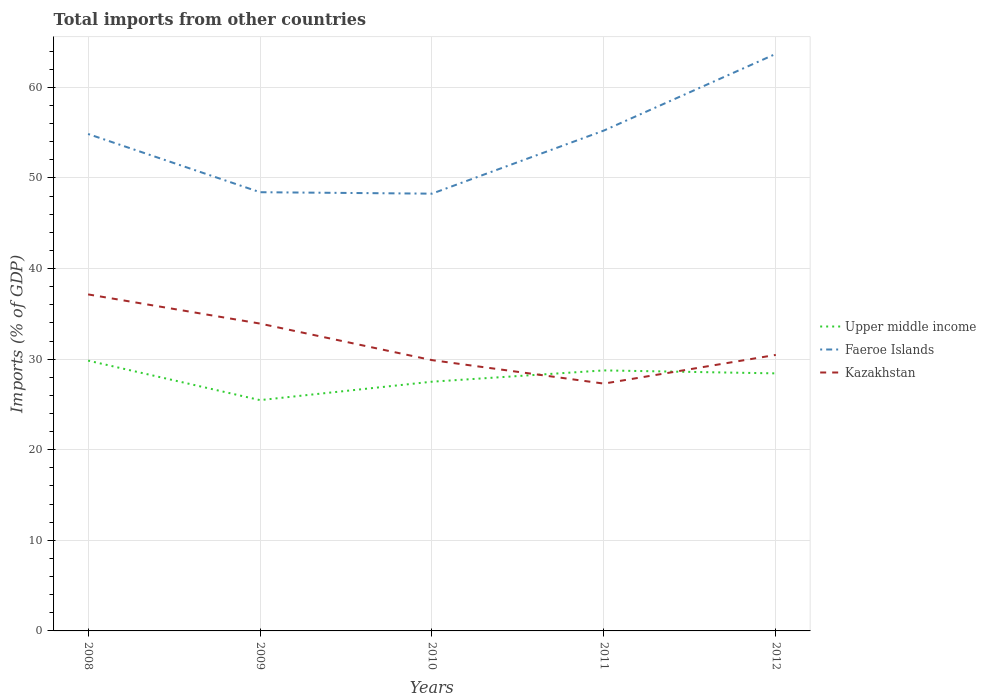How many different coloured lines are there?
Provide a succinct answer. 3. Is the number of lines equal to the number of legend labels?
Offer a terse response. Yes. Across all years, what is the maximum total imports in Faeroe Islands?
Your response must be concise. 48.27. In which year was the total imports in Upper middle income maximum?
Provide a short and direct response. 2009. What is the total total imports in Upper middle income in the graph?
Your answer should be very brief. 4.36. What is the difference between the highest and the second highest total imports in Kazakhstan?
Offer a very short reply. 9.85. What is the difference between the highest and the lowest total imports in Upper middle income?
Your response must be concise. 3. Is the total imports in Faeroe Islands strictly greater than the total imports in Upper middle income over the years?
Your answer should be compact. No. How many years are there in the graph?
Your answer should be compact. 5. What is the difference between two consecutive major ticks on the Y-axis?
Your response must be concise. 10. Where does the legend appear in the graph?
Your answer should be compact. Center right. How are the legend labels stacked?
Your answer should be compact. Vertical. What is the title of the graph?
Your answer should be compact. Total imports from other countries. Does "Iceland" appear as one of the legend labels in the graph?
Your answer should be very brief. No. What is the label or title of the X-axis?
Provide a succinct answer. Years. What is the label or title of the Y-axis?
Keep it short and to the point. Imports (% of GDP). What is the Imports (% of GDP) in Upper middle income in 2008?
Offer a very short reply. 29.84. What is the Imports (% of GDP) of Faeroe Islands in 2008?
Make the answer very short. 54.86. What is the Imports (% of GDP) in Kazakhstan in 2008?
Give a very brief answer. 37.15. What is the Imports (% of GDP) in Upper middle income in 2009?
Provide a short and direct response. 25.48. What is the Imports (% of GDP) of Faeroe Islands in 2009?
Offer a very short reply. 48.43. What is the Imports (% of GDP) in Kazakhstan in 2009?
Give a very brief answer. 33.93. What is the Imports (% of GDP) of Upper middle income in 2010?
Make the answer very short. 27.51. What is the Imports (% of GDP) of Faeroe Islands in 2010?
Your response must be concise. 48.27. What is the Imports (% of GDP) in Kazakhstan in 2010?
Keep it short and to the point. 29.89. What is the Imports (% of GDP) of Upper middle income in 2011?
Ensure brevity in your answer.  28.76. What is the Imports (% of GDP) in Faeroe Islands in 2011?
Your answer should be compact. 55.24. What is the Imports (% of GDP) of Kazakhstan in 2011?
Provide a short and direct response. 27.3. What is the Imports (% of GDP) in Upper middle income in 2012?
Your response must be concise. 28.43. What is the Imports (% of GDP) of Faeroe Islands in 2012?
Give a very brief answer. 63.7. What is the Imports (% of GDP) in Kazakhstan in 2012?
Give a very brief answer. 30.47. Across all years, what is the maximum Imports (% of GDP) of Upper middle income?
Provide a short and direct response. 29.84. Across all years, what is the maximum Imports (% of GDP) in Faeroe Islands?
Your response must be concise. 63.7. Across all years, what is the maximum Imports (% of GDP) of Kazakhstan?
Offer a very short reply. 37.15. Across all years, what is the minimum Imports (% of GDP) in Upper middle income?
Provide a succinct answer. 25.48. Across all years, what is the minimum Imports (% of GDP) in Faeroe Islands?
Give a very brief answer. 48.27. Across all years, what is the minimum Imports (% of GDP) of Kazakhstan?
Give a very brief answer. 27.3. What is the total Imports (% of GDP) in Upper middle income in the graph?
Give a very brief answer. 140.02. What is the total Imports (% of GDP) in Faeroe Islands in the graph?
Provide a short and direct response. 270.49. What is the total Imports (% of GDP) of Kazakhstan in the graph?
Your answer should be very brief. 158.74. What is the difference between the Imports (% of GDP) of Upper middle income in 2008 and that in 2009?
Ensure brevity in your answer.  4.36. What is the difference between the Imports (% of GDP) of Faeroe Islands in 2008 and that in 2009?
Provide a succinct answer. 6.43. What is the difference between the Imports (% of GDP) in Kazakhstan in 2008 and that in 2009?
Offer a very short reply. 3.22. What is the difference between the Imports (% of GDP) of Upper middle income in 2008 and that in 2010?
Your answer should be very brief. 2.33. What is the difference between the Imports (% of GDP) in Faeroe Islands in 2008 and that in 2010?
Keep it short and to the point. 6.59. What is the difference between the Imports (% of GDP) in Kazakhstan in 2008 and that in 2010?
Offer a very short reply. 7.25. What is the difference between the Imports (% of GDP) of Upper middle income in 2008 and that in 2011?
Your answer should be compact. 1.08. What is the difference between the Imports (% of GDP) of Faeroe Islands in 2008 and that in 2011?
Keep it short and to the point. -0.38. What is the difference between the Imports (% of GDP) of Kazakhstan in 2008 and that in 2011?
Give a very brief answer. 9.85. What is the difference between the Imports (% of GDP) of Upper middle income in 2008 and that in 2012?
Give a very brief answer. 1.41. What is the difference between the Imports (% of GDP) of Faeroe Islands in 2008 and that in 2012?
Give a very brief answer. -8.84. What is the difference between the Imports (% of GDP) of Kazakhstan in 2008 and that in 2012?
Your answer should be very brief. 6.68. What is the difference between the Imports (% of GDP) in Upper middle income in 2009 and that in 2010?
Offer a very short reply. -2.03. What is the difference between the Imports (% of GDP) of Faeroe Islands in 2009 and that in 2010?
Your response must be concise. 0.16. What is the difference between the Imports (% of GDP) in Kazakhstan in 2009 and that in 2010?
Give a very brief answer. 4.03. What is the difference between the Imports (% of GDP) of Upper middle income in 2009 and that in 2011?
Offer a very short reply. -3.28. What is the difference between the Imports (% of GDP) in Faeroe Islands in 2009 and that in 2011?
Your answer should be compact. -6.81. What is the difference between the Imports (% of GDP) in Kazakhstan in 2009 and that in 2011?
Give a very brief answer. 6.63. What is the difference between the Imports (% of GDP) of Upper middle income in 2009 and that in 2012?
Keep it short and to the point. -2.95. What is the difference between the Imports (% of GDP) in Faeroe Islands in 2009 and that in 2012?
Provide a short and direct response. -15.27. What is the difference between the Imports (% of GDP) of Kazakhstan in 2009 and that in 2012?
Offer a very short reply. 3.46. What is the difference between the Imports (% of GDP) of Upper middle income in 2010 and that in 2011?
Provide a short and direct response. -1.25. What is the difference between the Imports (% of GDP) in Faeroe Islands in 2010 and that in 2011?
Ensure brevity in your answer.  -6.97. What is the difference between the Imports (% of GDP) in Kazakhstan in 2010 and that in 2011?
Provide a short and direct response. 2.59. What is the difference between the Imports (% of GDP) of Upper middle income in 2010 and that in 2012?
Make the answer very short. -0.92. What is the difference between the Imports (% of GDP) in Faeroe Islands in 2010 and that in 2012?
Your answer should be very brief. -15.43. What is the difference between the Imports (% of GDP) of Kazakhstan in 2010 and that in 2012?
Offer a very short reply. -0.58. What is the difference between the Imports (% of GDP) of Upper middle income in 2011 and that in 2012?
Make the answer very short. 0.33. What is the difference between the Imports (% of GDP) of Faeroe Islands in 2011 and that in 2012?
Your response must be concise. -8.46. What is the difference between the Imports (% of GDP) in Kazakhstan in 2011 and that in 2012?
Make the answer very short. -3.17. What is the difference between the Imports (% of GDP) of Upper middle income in 2008 and the Imports (% of GDP) of Faeroe Islands in 2009?
Provide a succinct answer. -18.59. What is the difference between the Imports (% of GDP) of Upper middle income in 2008 and the Imports (% of GDP) of Kazakhstan in 2009?
Keep it short and to the point. -4.09. What is the difference between the Imports (% of GDP) of Faeroe Islands in 2008 and the Imports (% of GDP) of Kazakhstan in 2009?
Your answer should be compact. 20.93. What is the difference between the Imports (% of GDP) of Upper middle income in 2008 and the Imports (% of GDP) of Faeroe Islands in 2010?
Provide a short and direct response. -18.43. What is the difference between the Imports (% of GDP) of Upper middle income in 2008 and the Imports (% of GDP) of Kazakhstan in 2010?
Provide a short and direct response. -0.05. What is the difference between the Imports (% of GDP) in Faeroe Islands in 2008 and the Imports (% of GDP) in Kazakhstan in 2010?
Offer a very short reply. 24.96. What is the difference between the Imports (% of GDP) of Upper middle income in 2008 and the Imports (% of GDP) of Faeroe Islands in 2011?
Ensure brevity in your answer.  -25.4. What is the difference between the Imports (% of GDP) of Upper middle income in 2008 and the Imports (% of GDP) of Kazakhstan in 2011?
Provide a short and direct response. 2.54. What is the difference between the Imports (% of GDP) of Faeroe Islands in 2008 and the Imports (% of GDP) of Kazakhstan in 2011?
Offer a very short reply. 27.55. What is the difference between the Imports (% of GDP) in Upper middle income in 2008 and the Imports (% of GDP) in Faeroe Islands in 2012?
Your response must be concise. -33.86. What is the difference between the Imports (% of GDP) of Upper middle income in 2008 and the Imports (% of GDP) of Kazakhstan in 2012?
Ensure brevity in your answer.  -0.63. What is the difference between the Imports (% of GDP) in Faeroe Islands in 2008 and the Imports (% of GDP) in Kazakhstan in 2012?
Your response must be concise. 24.39. What is the difference between the Imports (% of GDP) of Upper middle income in 2009 and the Imports (% of GDP) of Faeroe Islands in 2010?
Offer a very short reply. -22.79. What is the difference between the Imports (% of GDP) in Upper middle income in 2009 and the Imports (% of GDP) in Kazakhstan in 2010?
Provide a succinct answer. -4.42. What is the difference between the Imports (% of GDP) of Faeroe Islands in 2009 and the Imports (% of GDP) of Kazakhstan in 2010?
Provide a succinct answer. 18.54. What is the difference between the Imports (% of GDP) in Upper middle income in 2009 and the Imports (% of GDP) in Faeroe Islands in 2011?
Keep it short and to the point. -29.76. What is the difference between the Imports (% of GDP) in Upper middle income in 2009 and the Imports (% of GDP) in Kazakhstan in 2011?
Offer a very short reply. -1.82. What is the difference between the Imports (% of GDP) in Faeroe Islands in 2009 and the Imports (% of GDP) in Kazakhstan in 2011?
Your response must be concise. 21.13. What is the difference between the Imports (% of GDP) in Upper middle income in 2009 and the Imports (% of GDP) in Faeroe Islands in 2012?
Provide a short and direct response. -38.22. What is the difference between the Imports (% of GDP) of Upper middle income in 2009 and the Imports (% of GDP) of Kazakhstan in 2012?
Provide a succinct answer. -4.99. What is the difference between the Imports (% of GDP) in Faeroe Islands in 2009 and the Imports (% of GDP) in Kazakhstan in 2012?
Make the answer very short. 17.96. What is the difference between the Imports (% of GDP) in Upper middle income in 2010 and the Imports (% of GDP) in Faeroe Islands in 2011?
Keep it short and to the point. -27.72. What is the difference between the Imports (% of GDP) in Upper middle income in 2010 and the Imports (% of GDP) in Kazakhstan in 2011?
Make the answer very short. 0.21. What is the difference between the Imports (% of GDP) of Faeroe Islands in 2010 and the Imports (% of GDP) of Kazakhstan in 2011?
Give a very brief answer. 20.97. What is the difference between the Imports (% of GDP) of Upper middle income in 2010 and the Imports (% of GDP) of Faeroe Islands in 2012?
Make the answer very short. -36.19. What is the difference between the Imports (% of GDP) of Upper middle income in 2010 and the Imports (% of GDP) of Kazakhstan in 2012?
Provide a short and direct response. -2.96. What is the difference between the Imports (% of GDP) in Faeroe Islands in 2010 and the Imports (% of GDP) in Kazakhstan in 2012?
Give a very brief answer. 17.8. What is the difference between the Imports (% of GDP) of Upper middle income in 2011 and the Imports (% of GDP) of Faeroe Islands in 2012?
Your response must be concise. -34.94. What is the difference between the Imports (% of GDP) of Upper middle income in 2011 and the Imports (% of GDP) of Kazakhstan in 2012?
Provide a short and direct response. -1.71. What is the difference between the Imports (% of GDP) in Faeroe Islands in 2011 and the Imports (% of GDP) in Kazakhstan in 2012?
Your response must be concise. 24.77. What is the average Imports (% of GDP) of Upper middle income per year?
Provide a short and direct response. 28. What is the average Imports (% of GDP) of Faeroe Islands per year?
Your answer should be compact. 54.1. What is the average Imports (% of GDP) in Kazakhstan per year?
Provide a succinct answer. 31.75. In the year 2008, what is the difference between the Imports (% of GDP) of Upper middle income and Imports (% of GDP) of Faeroe Islands?
Provide a succinct answer. -25.02. In the year 2008, what is the difference between the Imports (% of GDP) of Upper middle income and Imports (% of GDP) of Kazakhstan?
Your answer should be compact. -7.31. In the year 2008, what is the difference between the Imports (% of GDP) in Faeroe Islands and Imports (% of GDP) in Kazakhstan?
Offer a very short reply. 17.71. In the year 2009, what is the difference between the Imports (% of GDP) in Upper middle income and Imports (% of GDP) in Faeroe Islands?
Ensure brevity in your answer.  -22.95. In the year 2009, what is the difference between the Imports (% of GDP) of Upper middle income and Imports (% of GDP) of Kazakhstan?
Your answer should be very brief. -8.45. In the year 2009, what is the difference between the Imports (% of GDP) in Faeroe Islands and Imports (% of GDP) in Kazakhstan?
Keep it short and to the point. 14.5. In the year 2010, what is the difference between the Imports (% of GDP) of Upper middle income and Imports (% of GDP) of Faeroe Islands?
Ensure brevity in your answer.  -20.76. In the year 2010, what is the difference between the Imports (% of GDP) of Upper middle income and Imports (% of GDP) of Kazakhstan?
Provide a short and direct response. -2.38. In the year 2010, what is the difference between the Imports (% of GDP) in Faeroe Islands and Imports (% of GDP) in Kazakhstan?
Keep it short and to the point. 18.38. In the year 2011, what is the difference between the Imports (% of GDP) in Upper middle income and Imports (% of GDP) in Faeroe Islands?
Offer a terse response. -26.48. In the year 2011, what is the difference between the Imports (% of GDP) in Upper middle income and Imports (% of GDP) in Kazakhstan?
Your response must be concise. 1.46. In the year 2011, what is the difference between the Imports (% of GDP) of Faeroe Islands and Imports (% of GDP) of Kazakhstan?
Your answer should be very brief. 27.93. In the year 2012, what is the difference between the Imports (% of GDP) of Upper middle income and Imports (% of GDP) of Faeroe Islands?
Offer a terse response. -35.27. In the year 2012, what is the difference between the Imports (% of GDP) in Upper middle income and Imports (% of GDP) in Kazakhstan?
Keep it short and to the point. -2.04. In the year 2012, what is the difference between the Imports (% of GDP) in Faeroe Islands and Imports (% of GDP) in Kazakhstan?
Offer a terse response. 33.23. What is the ratio of the Imports (% of GDP) in Upper middle income in 2008 to that in 2009?
Your answer should be compact. 1.17. What is the ratio of the Imports (% of GDP) of Faeroe Islands in 2008 to that in 2009?
Your answer should be very brief. 1.13. What is the ratio of the Imports (% of GDP) of Kazakhstan in 2008 to that in 2009?
Give a very brief answer. 1.09. What is the ratio of the Imports (% of GDP) of Upper middle income in 2008 to that in 2010?
Provide a short and direct response. 1.08. What is the ratio of the Imports (% of GDP) of Faeroe Islands in 2008 to that in 2010?
Give a very brief answer. 1.14. What is the ratio of the Imports (% of GDP) of Kazakhstan in 2008 to that in 2010?
Keep it short and to the point. 1.24. What is the ratio of the Imports (% of GDP) of Upper middle income in 2008 to that in 2011?
Provide a succinct answer. 1.04. What is the ratio of the Imports (% of GDP) of Kazakhstan in 2008 to that in 2011?
Keep it short and to the point. 1.36. What is the ratio of the Imports (% of GDP) in Upper middle income in 2008 to that in 2012?
Give a very brief answer. 1.05. What is the ratio of the Imports (% of GDP) of Faeroe Islands in 2008 to that in 2012?
Offer a very short reply. 0.86. What is the ratio of the Imports (% of GDP) of Kazakhstan in 2008 to that in 2012?
Your response must be concise. 1.22. What is the ratio of the Imports (% of GDP) of Upper middle income in 2009 to that in 2010?
Offer a very short reply. 0.93. What is the ratio of the Imports (% of GDP) of Faeroe Islands in 2009 to that in 2010?
Provide a short and direct response. 1. What is the ratio of the Imports (% of GDP) in Kazakhstan in 2009 to that in 2010?
Keep it short and to the point. 1.13. What is the ratio of the Imports (% of GDP) of Upper middle income in 2009 to that in 2011?
Your answer should be very brief. 0.89. What is the ratio of the Imports (% of GDP) of Faeroe Islands in 2009 to that in 2011?
Your answer should be compact. 0.88. What is the ratio of the Imports (% of GDP) in Kazakhstan in 2009 to that in 2011?
Offer a terse response. 1.24. What is the ratio of the Imports (% of GDP) in Upper middle income in 2009 to that in 2012?
Your response must be concise. 0.9. What is the ratio of the Imports (% of GDP) in Faeroe Islands in 2009 to that in 2012?
Offer a terse response. 0.76. What is the ratio of the Imports (% of GDP) of Kazakhstan in 2009 to that in 2012?
Your answer should be very brief. 1.11. What is the ratio of the Imports (% of GDP) in Upper middle income in 2010 to that in 2011?
Your response must be concise. 0.96. What is the ratio of the Imports (% of GDP) in Faeroe Islands in 2010 to that in 2011?
Make the answer very short. 0.87. What is the ratio of the Imports (% of GDP) in Kazakhstan in 2010 to that in 2011?
Offer a very short reply. 1.09. What is the ratio of the Imports (% of GDP) of Faeroe Islands in 2010 to that in 2012?
Offer a very short reply. 0.76. What is the ratio of the Imports (% of GDP) in Kazakhstan in 2010 to that in 2012?
Provide a short and direct response. 0.98. What is the ratio of the Imports (% of GDP) in Upper middle income in 2011 to that in 2012?
Offer a terse response. 1.01. What is the ratio of the Imports (% of GDP) of Faeroe Islands in 2011 to that in 2012?
Give a very brief answer. 0.87. What is the ratio of the Imports (% of GDP) in Kazakhstan in 2011 to that in 2012?
Offer a terse response. 0.9. What is the difference between the highest and the second highest Imports (% of GDP) in Upper middle income?
Offer a terse response. 1.08. What is the difference between the highest and the second highest Imports (% of GDP) in Faeroe Islands?
Your answer should be very brief. 8.46. What is the difference between the highest and the second highest Imports (% of GDP) of Kazakhstan?
Provide a short and direct response. 3.22. What is the difference between the highest and the lowest Imports (% of GDP) in Upper middle income?
Make the answer very short. 4.36. What is the difference between the highest and the lowest Imports (% of GDP) in Faeroe Islands?
Make the answer very short. 15.43. What is the difference between the highest and the lowest Imports (% of GDP) of Kazakhstan?
Give a very brief answer. 9.85. 